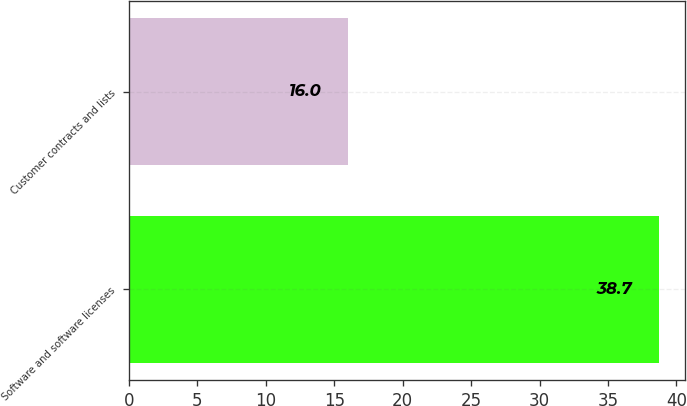Convert chart. <chart><loc_0><loc_0><loc_500><loc_500><bar_chart><fcel>Software and software licenses<fcel>Customer contracts and lists<nl><fcel>38.7<fcel>16<nl></chart> 